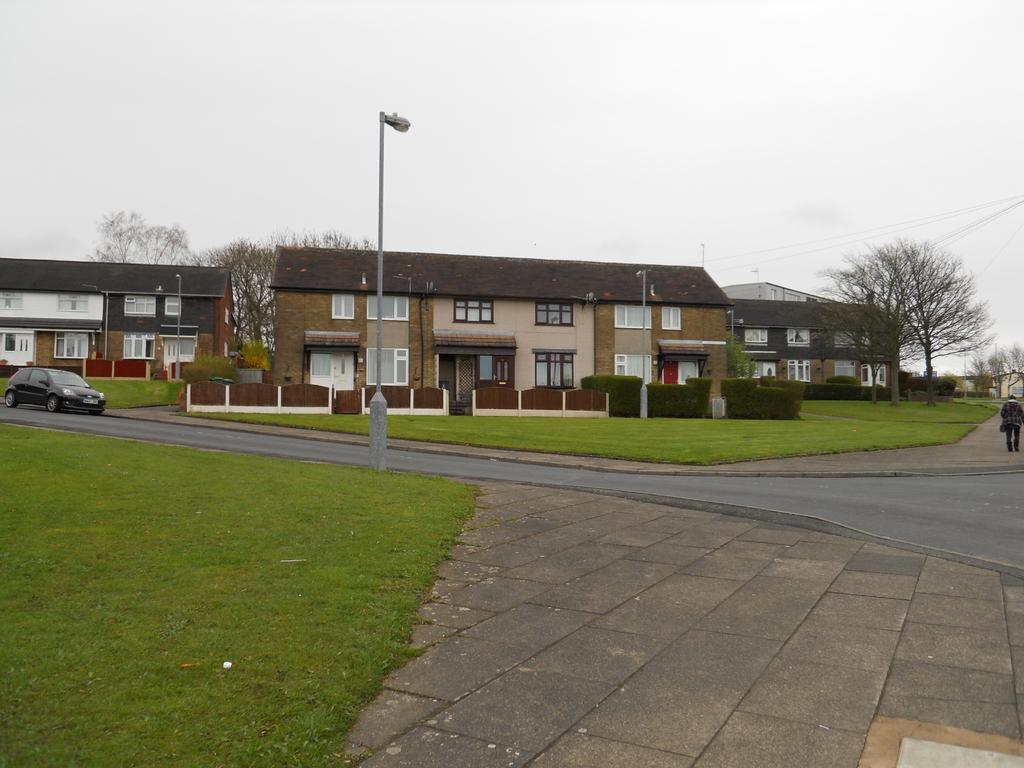Describe this image in one or two sentences. In this image there is a road in middle of this image and there are some buildings in the background. There is a car at left side of this image and there are some trees at left side of this image and right side of this image as well. There is a sky at top of this image and there is a pole in middle of this image, and there is some grass at bottom left side of this image and middle of this image as well. There is one person standing at right side of this image. 